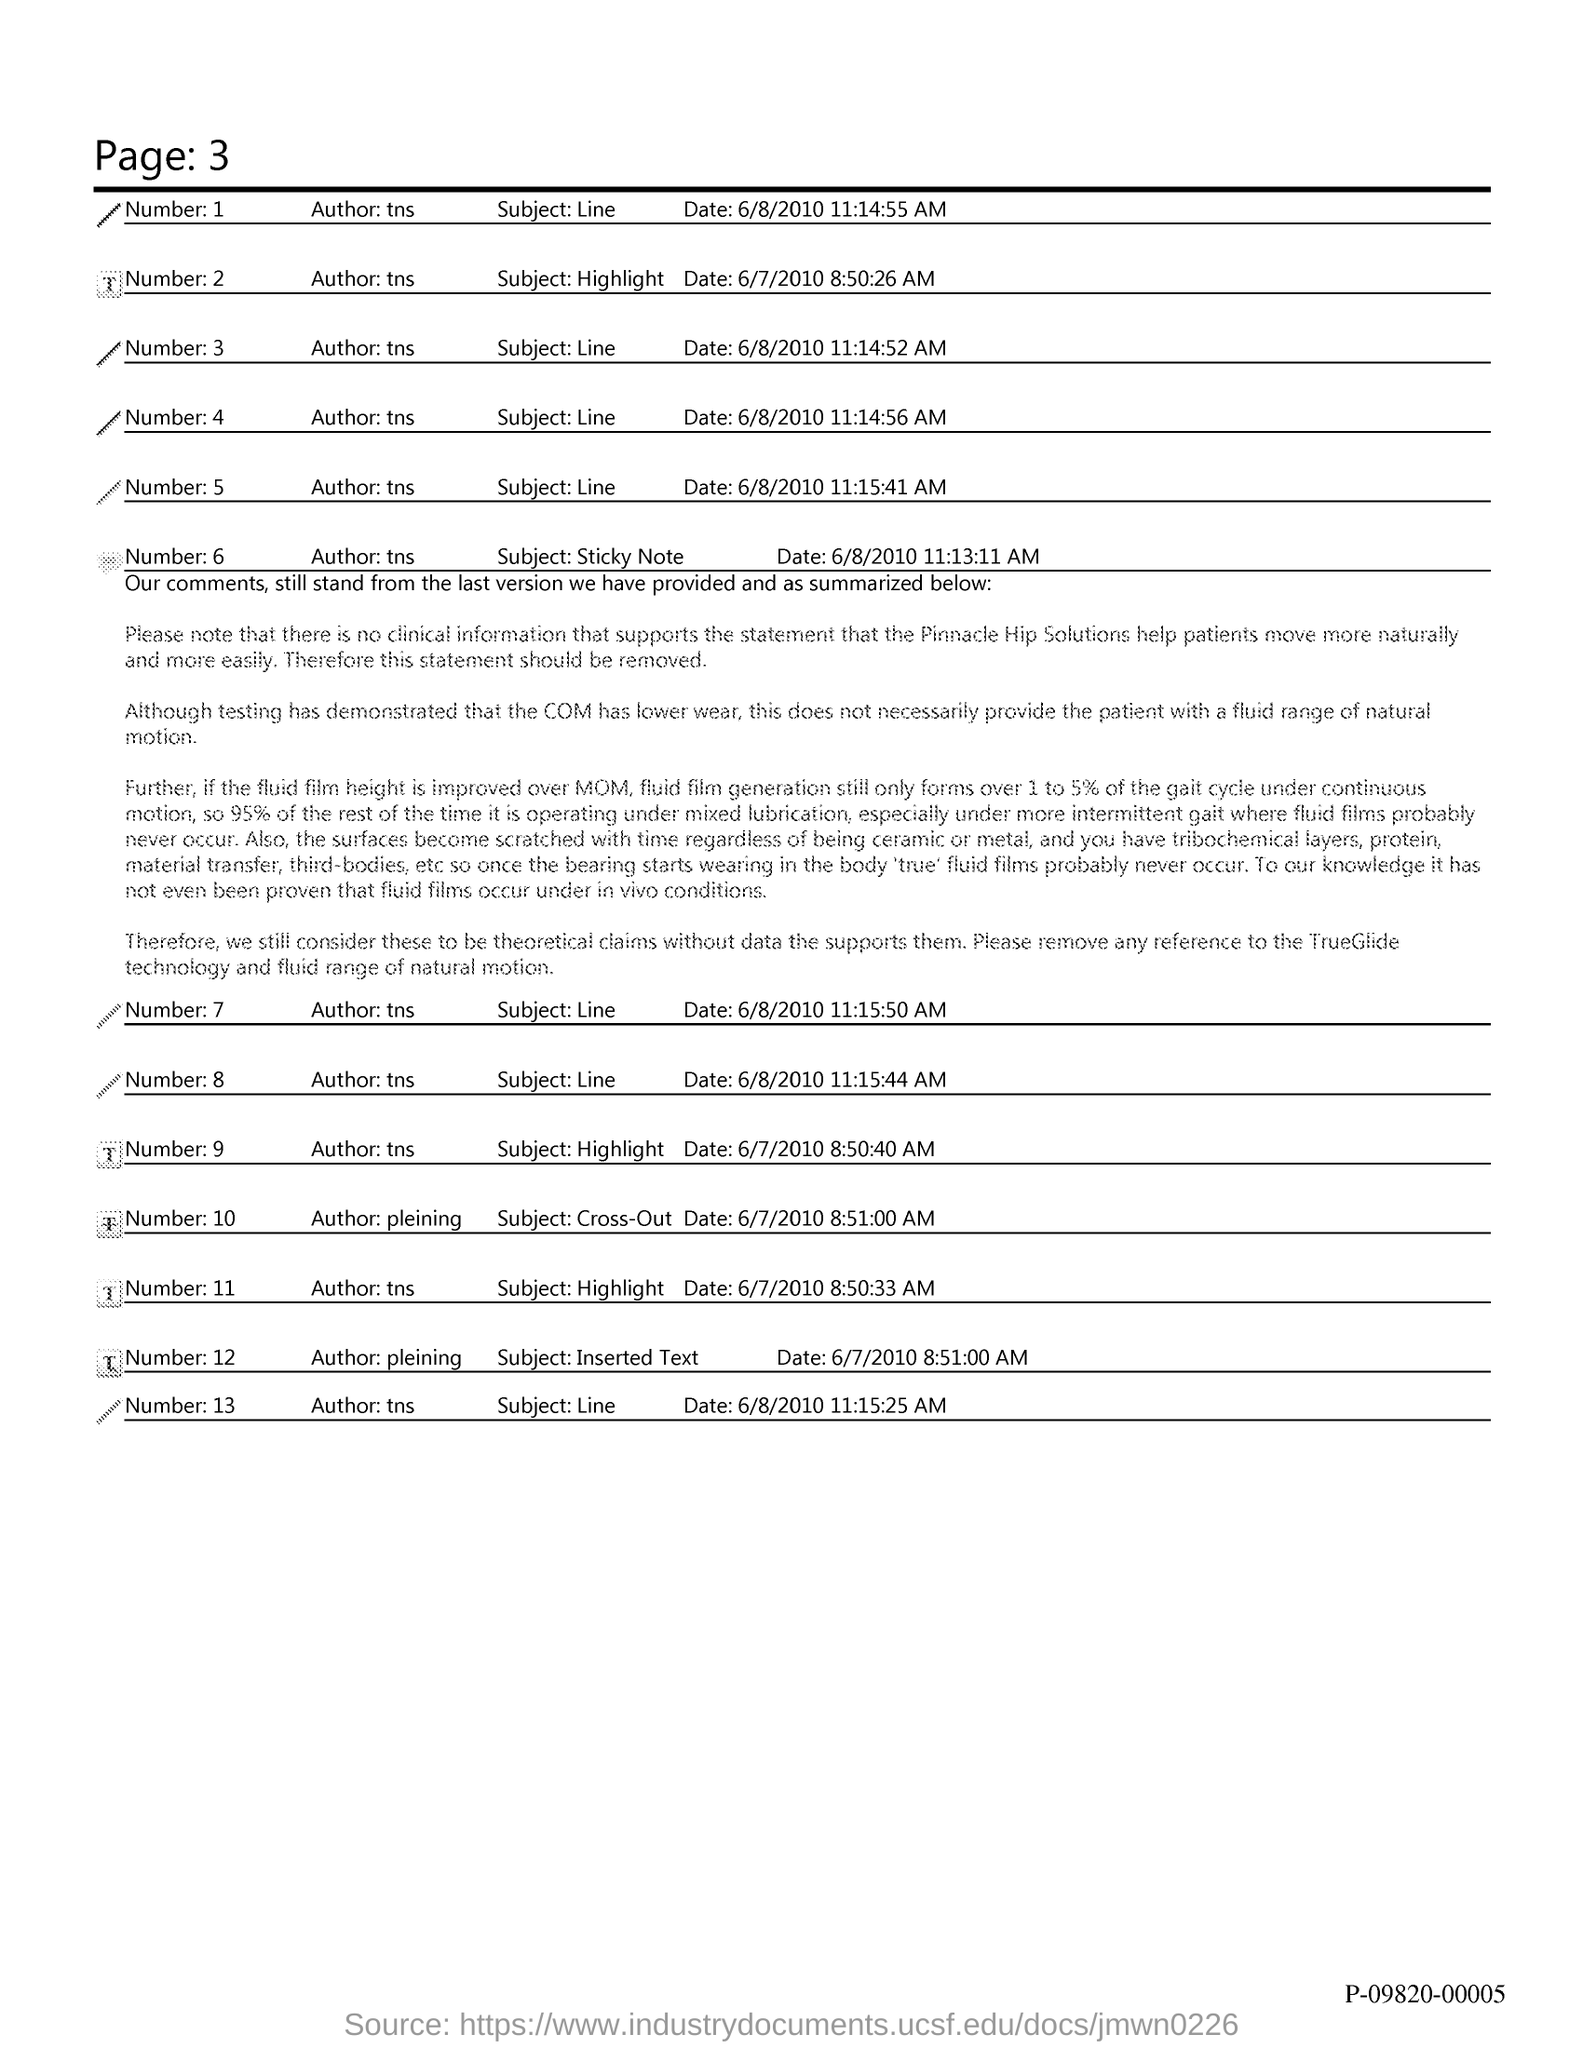What is the Page Number?
Your response must be concise. 3. What is the subject mentioned with Number 6?
Keep it short and to the point. Sticky note. What is the subject mentioned with Number 3?
Your answer should be very brief. Line. 